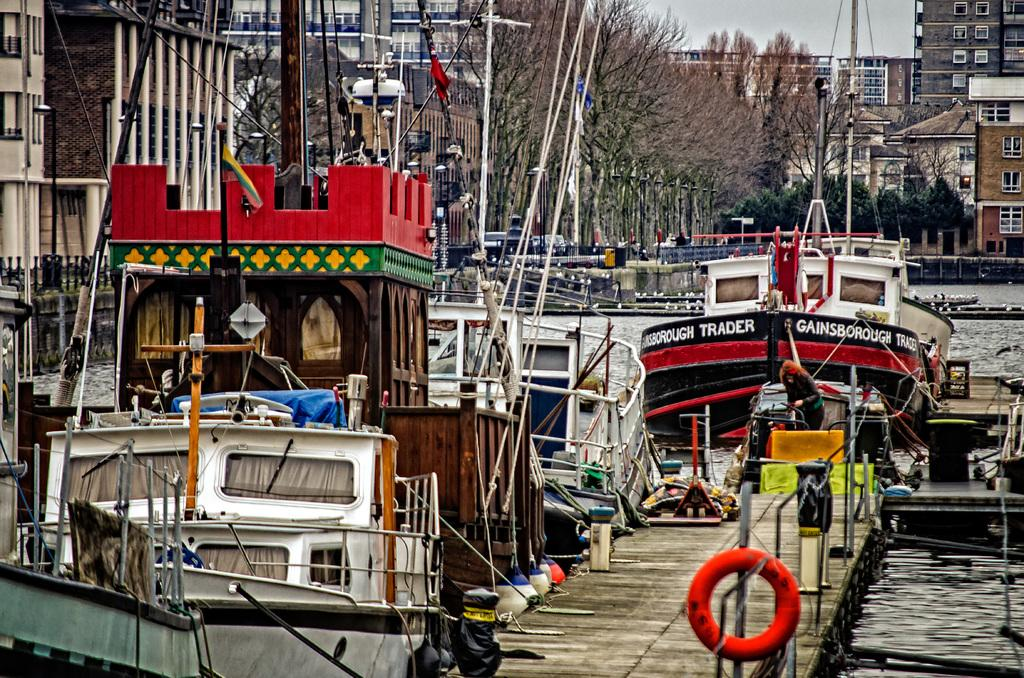What type of watercraft can be seen in the image? There are boats and ships in the image. What location might the image depict? The image appears to depict a shipyard. What can be seen in the background of the image? There are trees, buildings, and the sky visible in the background of the image. What type of rod is being used to thread the manager in the image? There is no manager, rod, or thread present in the image. 